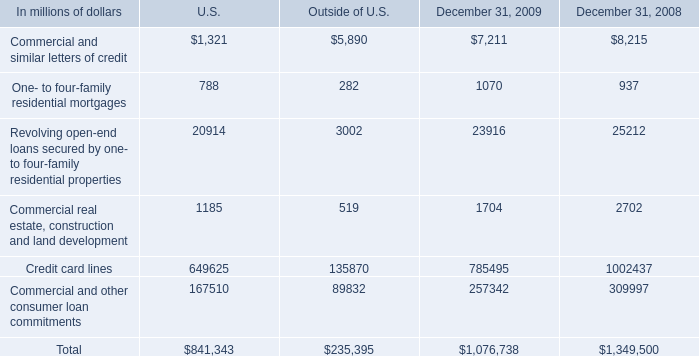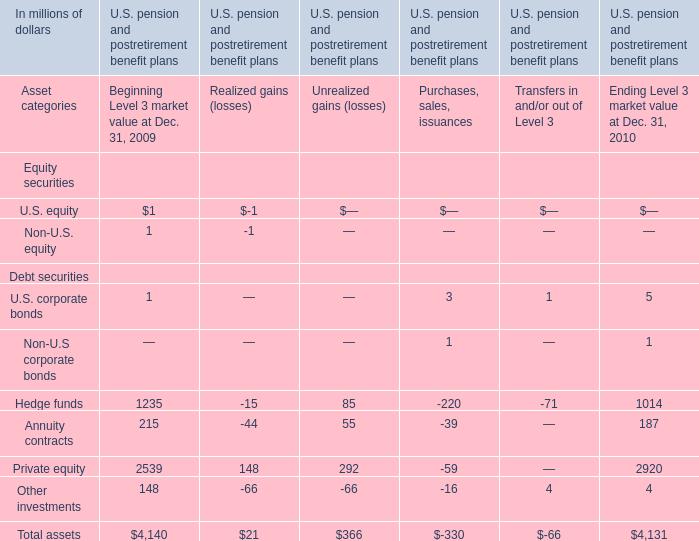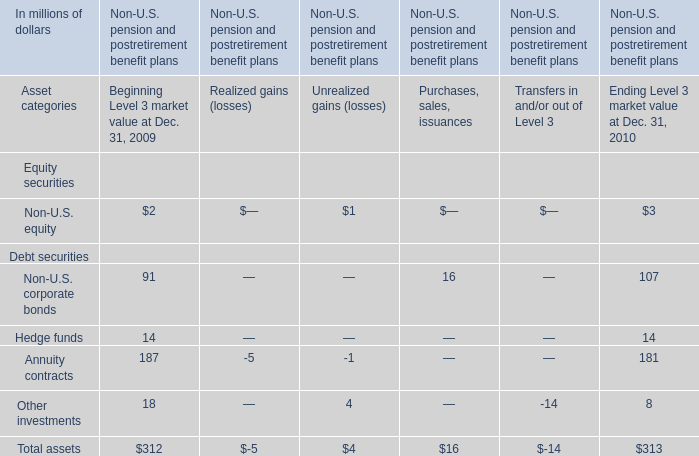what was the percentage decrease the credit card lines from 2008 to 2009 
Computations: ((785495 - 1002437) / 1002437)
Answer: -0.21641. 